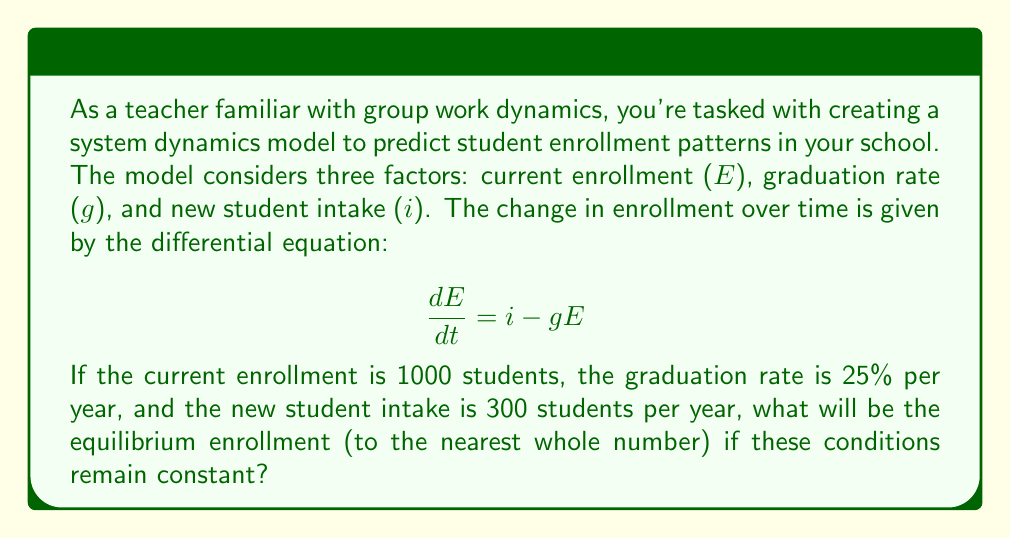Can you solve this math problem? Let's approach this step-by-step:

1) The equilibrium enrollment is reached when the change in enrollment over time is zero. Mathematically, this means:

   $$\frac{dE}{dt} = 0$$

2) Substituting this into our original equation:

   $$0 = i - gE$$

3) Now, let's substitute the given values:
   - $i = 300$ (new student intake per year)
   - $g = 0.25$ (25% graduation rate per year)

   $$0 = 300 - 0.25E$$

4) Solving for $E$:

   $$0.25E = 300$$
   $$E = \frac{300}{0.25} = 1200$$

5) Therefore, the equilibrium enrollment is 1200 students.

This makes intuitive sense: at equilibrium, the number of new students (300) equals the number of graduating students (25% of 1200 = 300).
Answer: 1200 students 